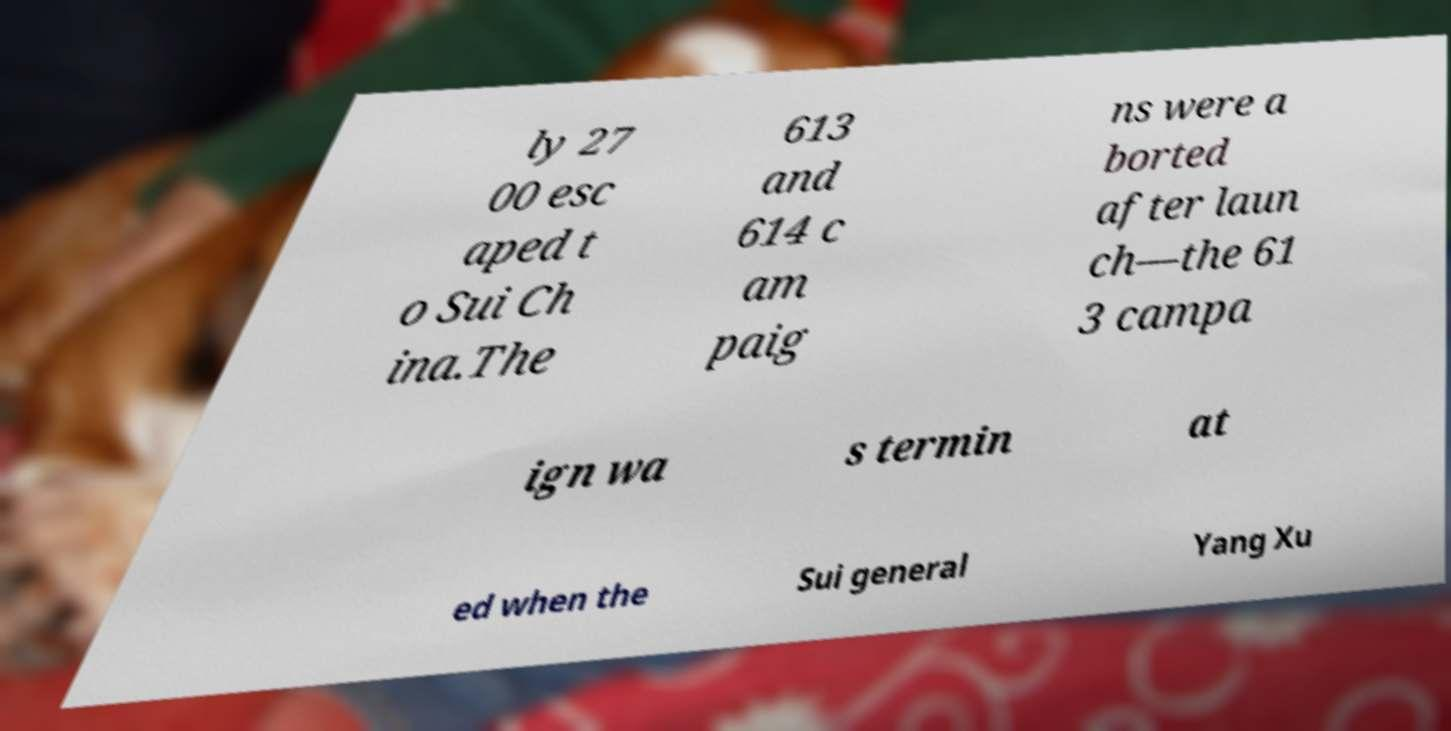For documentation purposes, I need the text within this image transcribed. Could you provide that? ly 27 00 esc aped t o Sui Ch ina.The 613 and 614 c am paig ns were a borted after laun ch—the 61 3 campa ign wa s termin at ed when the Sui general Yang Xu 